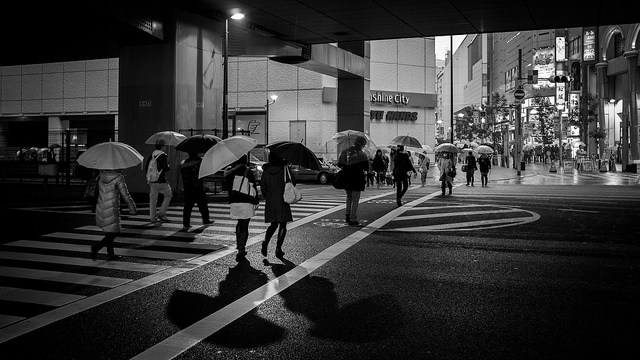Please transcribe the text in this image. Shine City 